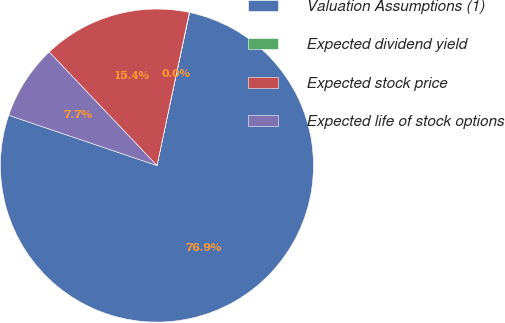Convert chart. <chart><loc_0><loc_0><loc_500><loc_500><pie_chart><fcel>Valuation Assumptions (1)<fcel>Expected dividend yield<fcel>Expected stock price<fcel>Expected life of stock options<nl><fcel>76.86%<fcel>0.03%<fcel>15.4%<fcel>7.71%<nl></chart> 